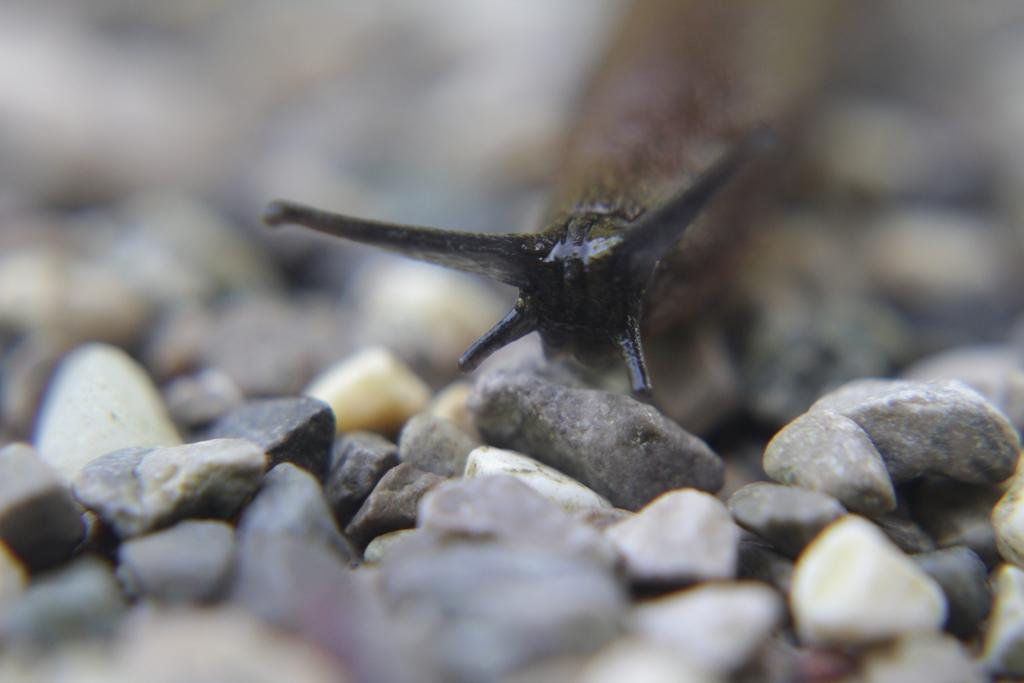What is the main subject of the picture? The main subject of the picture is a snail. What is the snail doing in the picture? The snail is moving on the stones in the picture. Can you describe the snail's appearance? The snail has a black head. What type of surface is the snail moving on? There are stones and pebbles on the floor in the picture. What type of crayon is the snail holding in its mouth in the image? There is no crayon present in the image, and the snail is not holding anything in its mouth. How many apples are visible on the stones in the image? There are no apples present in the image; it only features a snail moving on the stones. 